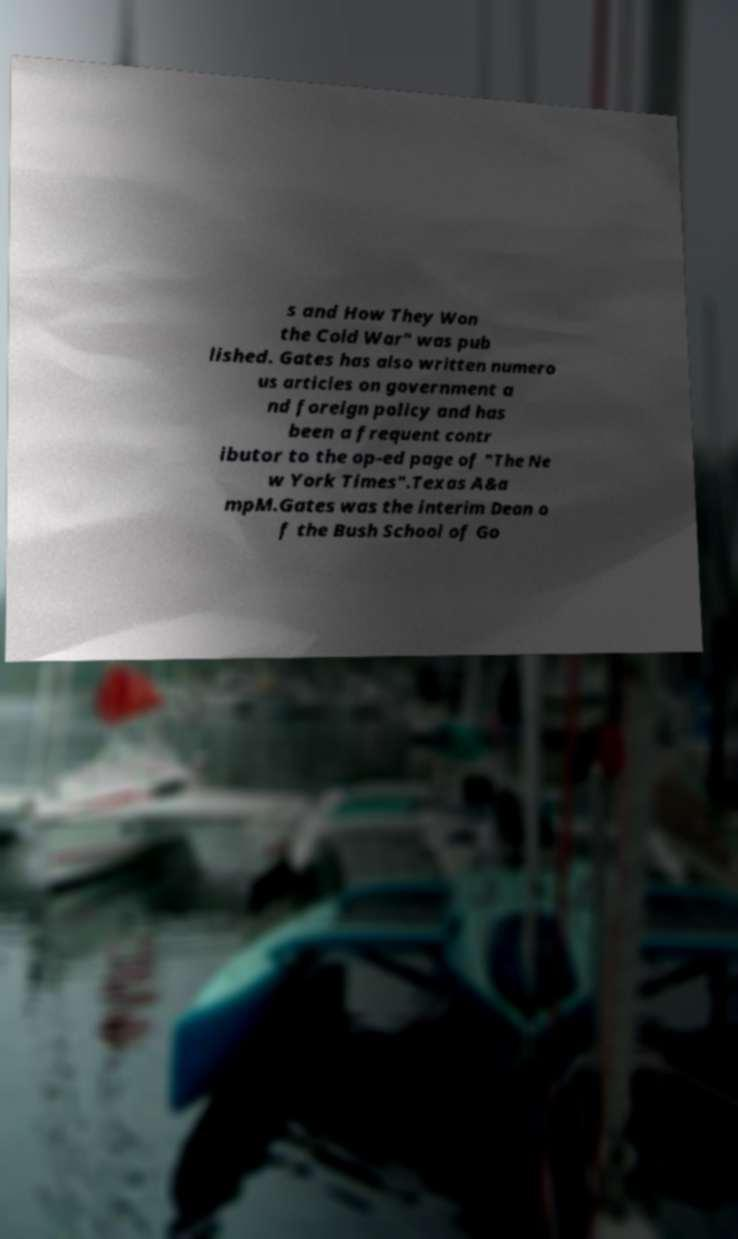What messages or text are displayed in this image? I need them in a readable, typed format. s and How They Won the Cold War" was pub lished. Gates has also written numero us articles on government a nd foreign policy and has been a frequent contr ibutor to the op-ed page of "The Ne w York Times".Texas A&a mpM.Gates was the interim Dean o f the Bush School of Go 